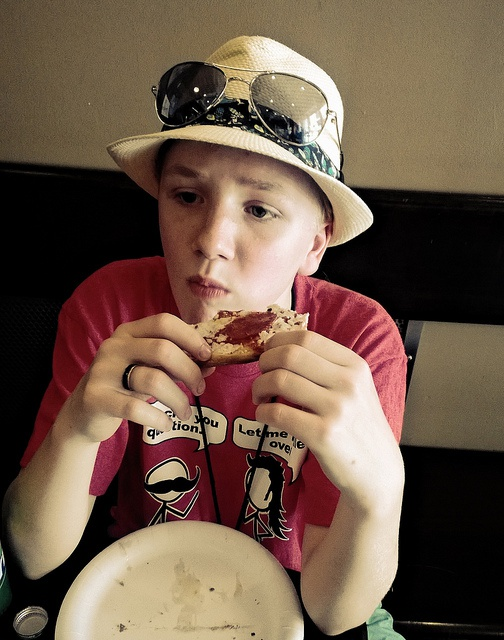Describe the objects in this image and their specific colors. I can see people in black, maroon, lightgray, and gray tones, bench in black, gray, and maroon tones, chair in black and gray tones, and pizza in black, maroon, tan, and brown tones in this image. 